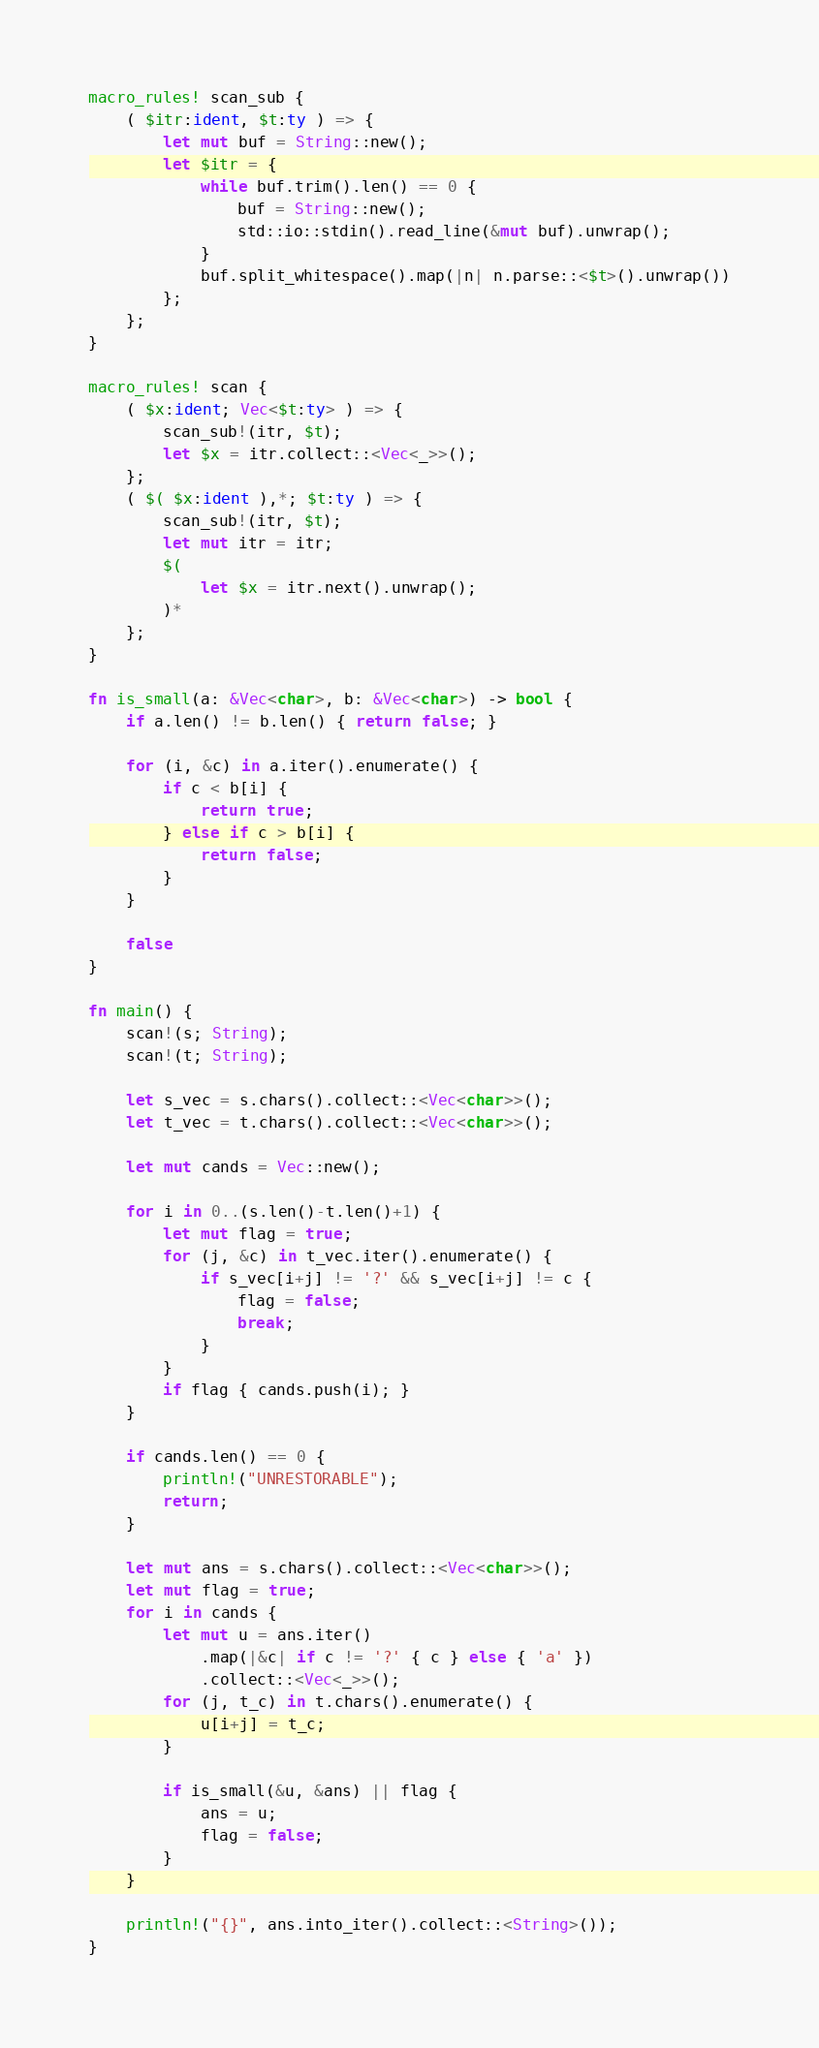<code> <loc_0><loc_0><loc_500><loc_500><_Rust_>macro_rules! scan_sub {
    ( $itr:ident, $t:ty ) => {
        let mut buf = String::new();
        let $itr = {
            while buf.trim().len() == 0 {
                buf = String::new();
                std::io::stdin().read_line(&mut buf).unwrap();
            }
            buf.split_whitespace().map(|n| n.parse::<$t>().unwrap())
        };
    };
}

macro_rules! scan {
    ( $x:ident; Vec<$t:ty> ) => {
        scan_sub!(itr, $t);
        let $x = itr.collect::<Vec<_>>();
    };
    ( $( $x:ident ),*; $t:ty ) => {
        scan_sub!(itr, $t);
        let mut itr = itr;
        $(
            let $x = itr.next().unwrap();
        )*
    };
}

fn is_small(a: &Vec<char>, b: &Vec<char>) -> bool {
    if a.len() != b.len() { return false; }

    for (i, &c) in a.iter().enumerate() {
        if c < b[i] {
            return true;
        } else if c > b[i] {
            return false;
        }
    }

    false
}

fn main() {
    scan!(s; String);
    scan!(t; String);

    let s_vec = s.chars().collect::<Vec<char>>();
    let t_vec = t.chars().collect::<Vec<char>>();

    let mut cands = Vec::new();

    for i in 0..(s.len()-t.len()+1) {
        let mut flag = true;
        for (j, &c) in t_vec.iter().enumerate() {
            if s_vec[i+j] != '?' && s_vec[i+j] != c {
                flag = false;
                break;
            }
        }
        if flag { cands.push(i); }
    }

    if cands.len() == 0 {
        println!("UNRESTORABLE");
        return;
    }

    let mut ans = s.chars().collect::<Vec<char>>();
    let mut flag = true;
    for i in cands {
        let mut u = ans.iter()
            .map(|&c| if c != '?' { c } else { 'a' })
            .collect::<Vec<_>>();
        for (j, t_c) in t.chars().enumerate() {
            u[i+j] = t_c;
        }

        if is_small(&u, &ans) || flag {
            ans = u;
            flag = false;
        }
    }

    println!("{}", ans.into_iter().collect::<String>());
}
</code> 